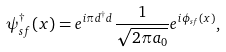Convert formula to latex. <formula><loc_0><loc_0><loc_500><loc_500>\psi _ { s f } ^ { \dagger } ( x ) = e ^ { i \pi d ^ { \dagger } d } \frac { 1 } { \sqrt { 2 \pi a _ { 0 } } } e ^ { i \phi _ { s f } ( x ) } ,</formula> 